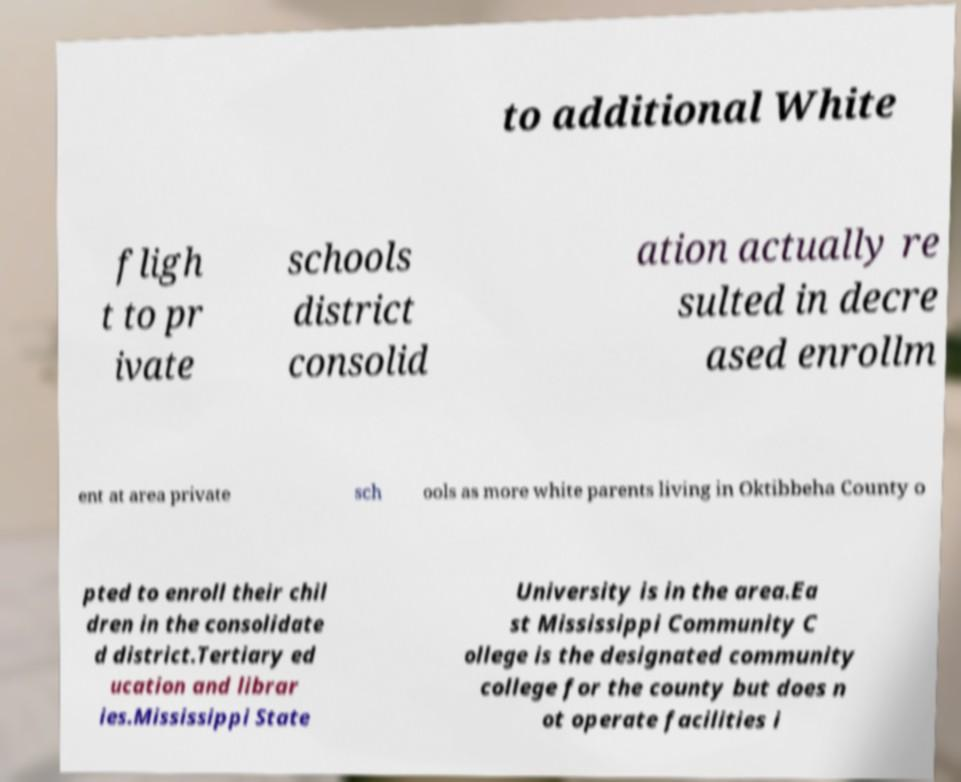Could you extract and type out the text from this image? to additional White fligh t to pr ivate schools district consolid ation actually re sulted in decre ased enrollm ent at area private sch ools as more white parents living in Oktibbeha County o pted to enroll their chil dren in the consolidate d district.Tertiary ed ucation and librar ies.Mississippi State University is in the area.Ea st Mississippi Community C ollege is the designated community college for the county but does n ot operate facilities i 